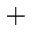<formula> <loc_0><loc_0><loc_500><loc_500>^ { + }</formula> 